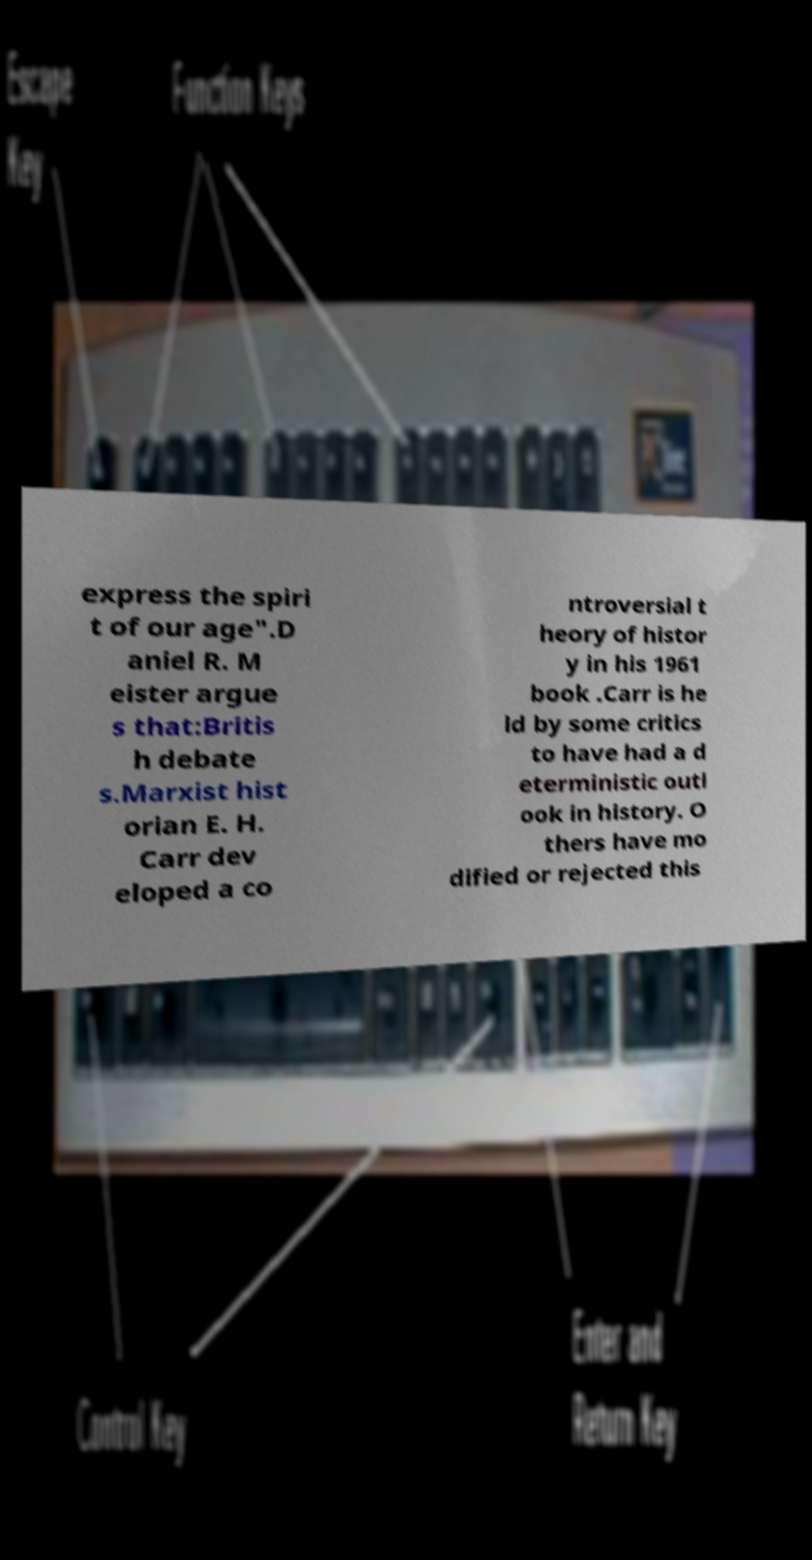What messages or text are displayed in this image? I need them in a readable, typed format. express the spiri t of our age".D aniel R. M eister argue s that:Britis h debate s.Marxist hist orian E. H. Carr dev eloped a co ntroversial t heory of histor y in his 1961 book .Carr is he ld by some critics to have had a d eterministic outl ook in history. O thers have mo dified or rejected this 